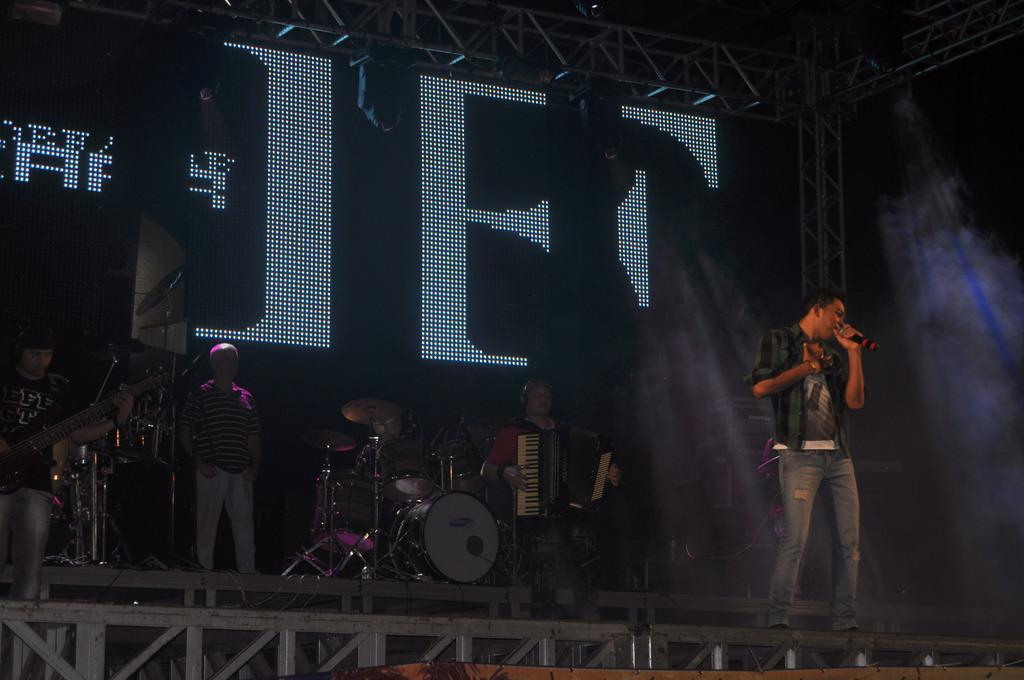How many people are on the stage in the image? There are four persons standing on a stage in the image. What are the people on the stage doing? One man is playing a musical instrument, one person is holding a microphone and singing, and one person is playing a guitar. What else can be seen on the stage besides the people? There are musical instruments present on the stage. What type of metal is used to make the straw in the image? There is no straw present in the image; it features four persons on a stage with musical instruments and people singing and playing. 